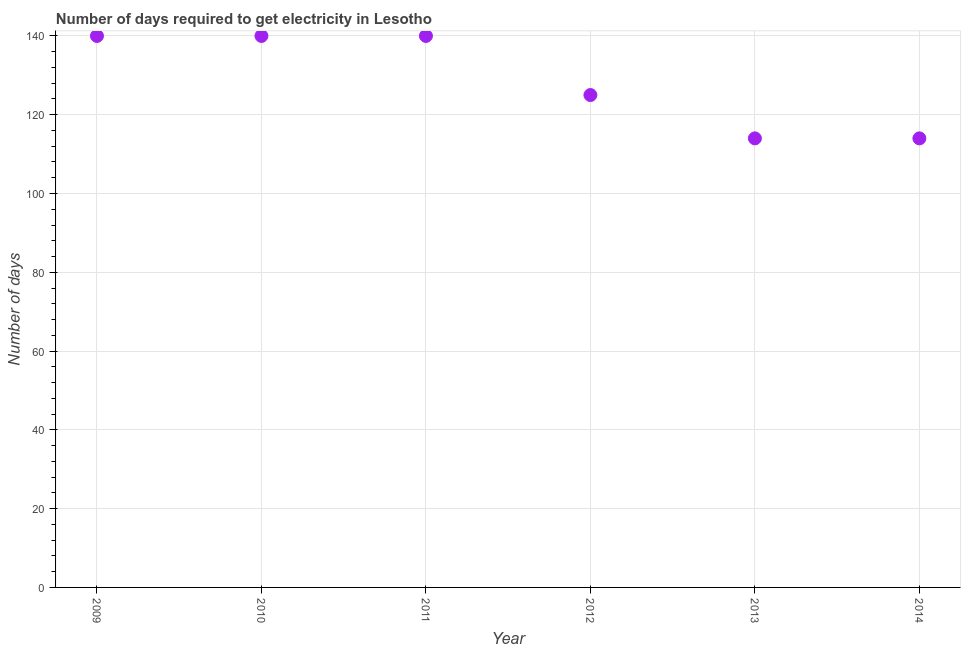What is the time to get electricity in 2011?
Make the answer very short. 140. Across all years, what is the maximum time to get electricity?
Give a very brief answer. 140. Across all years, what is the minimum time to get electricity?
Give a very brief answer. 114. In which year was the time to get electricity maximum?
Provide a short and direct response. 2009. In which year was the time to get electricity minimum?
Your answer should be compact. 2013. What is the sum of the time to get electricity?
Offer a very short reply. 773. What is the average time to get electricity per year?
Keep it short and to the point. 128.83. What is the median time to get electricity?
Ensure brevity in your answer.  132.5. In how many years, is the time to get electricity greater than 36 ?
Provide a succinct answer. 6. What is the ratio of the time to get electricity in 2010 to that in 2013?
Provide a succinct answer. 1.23. Is the difference between the time to get electricity in 2010 and 2014 greater than the difference between any two years?
Offer a very short reply. Yes. Is the sum of the time to get electricity in 2010 and 2014 greater than the maximum time to get electricity across all years?
Offer a terse response. Yes. What is the difference between the highest and the lowest time to get electricity?
Your response must be concise. 26. In how many years, is the time to get electricity greater than the average time to get electricity taken over all years?
Ensure brevity in your answer.  3. How many dotlines are there?
Keep it short and to the point. 1. What is the difference between two consecutive major ticks on the Y-axis?
Provide a short and direct response. 20. Does the graph contain grids?
Provide a succinct answer. Yes. What is the title of the graph?
Make the answer very short. Number of days required to get electricity in Lesotho. What is the label or title of the Y-axis?
Offer a very short reply. Number of days. What is the Number of days in 2009?
Make the answer very short. 140. What is the Number of days in 2010?
Provide a short and direct response. 140. What is the Number of days in 2011?
Keep it short and to the point. 140. What is the Number of days in 2012?
Your answer should be very brief. 125. What is the Number of days in 2013?
Offer a very short reply. 114. What is the Number of days in 2014?
Ensure brevity in your answer.  114. What is the difference between the Number of days in 2009 and 2011?
Offer a very short reply. 0. What is the difference between the Number of days in 2009 and 2012?
Provide a short and direct response. 15. What is the difference between the Number of days in 2009 and 2013?
Offer a terse response. 26. What is the difference between the Number of days in 2009 and 2014?
Make the answer very short. 26. What is the difference between the Number of days in 2010 and 2011?
Offer a very short reply. 0. What is the difference between the Number of days in 2010 and 2014?
Offer a terse response. 26. What is the difference between the Number of days in 2011 and 2014?
Your response must be concise. 26. What is the difference between the Number of days in 2012 and 2013?
Ensure brevity in your answer.  11. What is the difference between the Number of days in 2012 and 2014?
Provide a short and direct response. 11. What is the ratio of the Number of days in 2009 to that in 2012?
Make the answer very short. 1.12. What is the ratio of the Number of days in 2009 to that in 2013?
Keep it short and to the point. 1.23. What is the ratio of the Number of days in 2009 to that in 2014?
Give a very brief answer. 1.23. What is the ratio of the Number of days in 2010 to that in 2011?
Provide a succinct answer. 1. What is the ratio of the Number of days in 2010 to that in 2012?
Offer a terse response. 1.12. What is the ratio of the Number of days in 2010 to that in 2013?
Ensure brevity in your answer.  1.23. What is the ratio of the Number of days in 2010 to that in 2014?
Make the answer very short. 1.23. What is the ratio of the Number of days in 2011 to that in 2012?
Give a very brief answer. 1.12. What is the ratio of the Number of days in 2011 to that in 2013?
Offer a terse response. 1.23. What is the ratio of the Number of days in 2011 to that in 2014?
Offer a very short reply. 1.23. What is the ratio of the Number of days in 2012 to that in 2013?
Your answer should be very brief. 1.1. What is the ratio of the Number of days in 2012 to that in 2014?
Your answer should be very brief. 1.1. What is the ratio of the Number of days in 2013 to that in 2014?
Offer a very short reply. 1. 